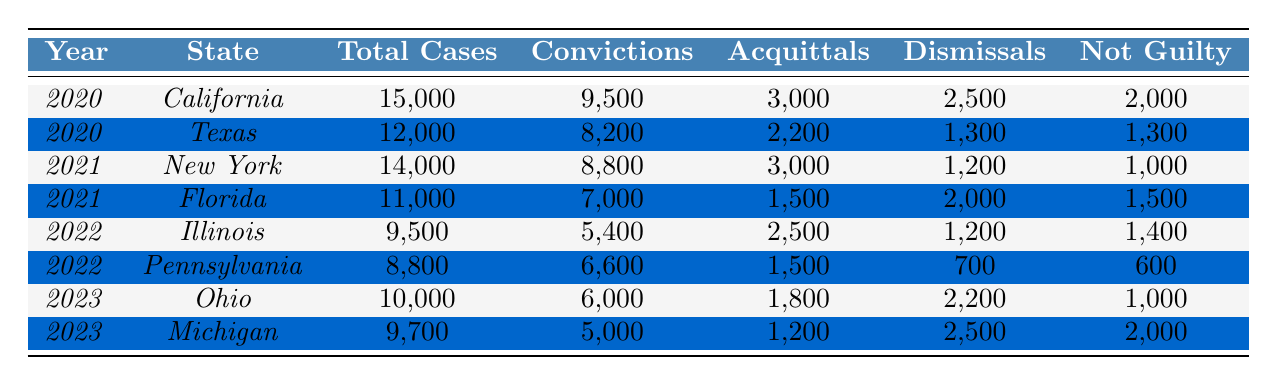What was the total number of cases in California in 2020? The table shows that for the year 2020 in California, the total number of cases is explicitly listed as 15,000.
Answer: 15,000 How many convictions were there in Texas in 2020? In the table, the number of convictions for Texas in 2020 is noted to be 8,200.
Answer: 8,200 Which state had the highest number of total cases in 2021? According to the table, New York had 14,000 cases and Florida had 11,000 cases in 2021. New York has the highest total.
Answer: New York What is the total number of acquittals across all states in 2020? For 2020, California had 3,000 acquittals and Texas had 2,200. Adding these gives 3,000 + 2,200 = 5,200.
Answer: 5,200 What percentage of cases resulted in convictions in Illinois in 2022? In 2022, Illinois had 9,500 total cases and 5,400 convictions. The percentage is calculated as (5,400 / 9,500) * 100 = 56.84%.
Answer: 56.84% Was the number of dismissals in Michigan greater than in Ohio in 2023? In 2023, Michigan had 2,500 dismissals while Ohio had 2,200 dismissals. Therefore, Michigan's dismissals are greater.
Answer: Yes How many more acquittals were there in 2021 than in 2022 across all states? In 2021, there were 3,000 acquittals (New York) + 1,500 acquittals (Florida) = 4,500. In 2022, Illinois had 2,500 acquittals and Pennsylvania had 1,500, totaling 4,000. The difference is 4,500 - 4,000 = 500.
Answer: 500 Which year had the highest total cases overall, and how many were there? Summing the total cases for each year: 2020 had 15,000 + 12,000 = 27,000; 2021 had 14,000 + 11,000 = 25,000; 2022 had 9,500 + 8,800 = 18,300; 2023 had 10,000 + 9,700 = 19,700. The highest is 27,000 in 2020.
Answer: 2020, 27,000 What was the total number of cases in 2022 and how does it compare to 2023? In 2022, the total cases were 9,500 (Illinois) + 8,800 (Pennsylvania) = 18,300. In 2023, it was 10,000 + 9,700 = 19,700. Thus, 19,700 is greater than 18,300.
Answer: 18,300, 2023 is greater Is it true that the number of acquittals in Pennsylvania was lower than in California in 2020? California had 3,000 acquittals while Pennsylvania is not in the 2020 data. Pennsylvania's data from 2022 lists 1,500 acquittals. Thus, 1,500 is indeed lower than 3,000.
Answer: Yes 